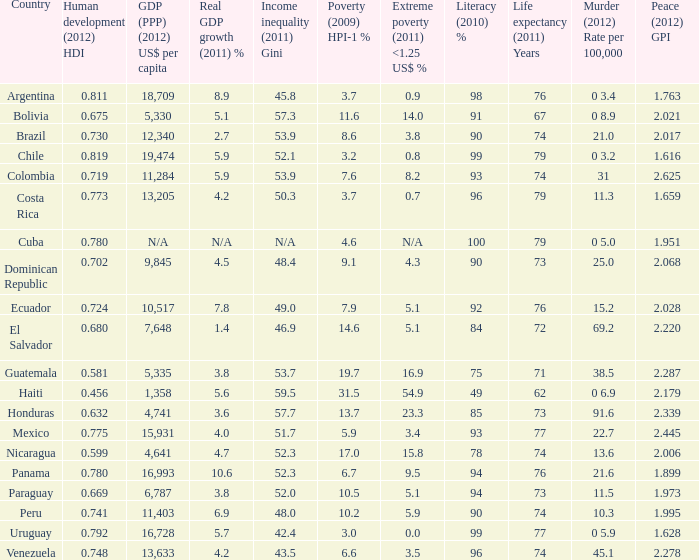What is the aggregate poverty (2009) hpi-1 % when the None. 